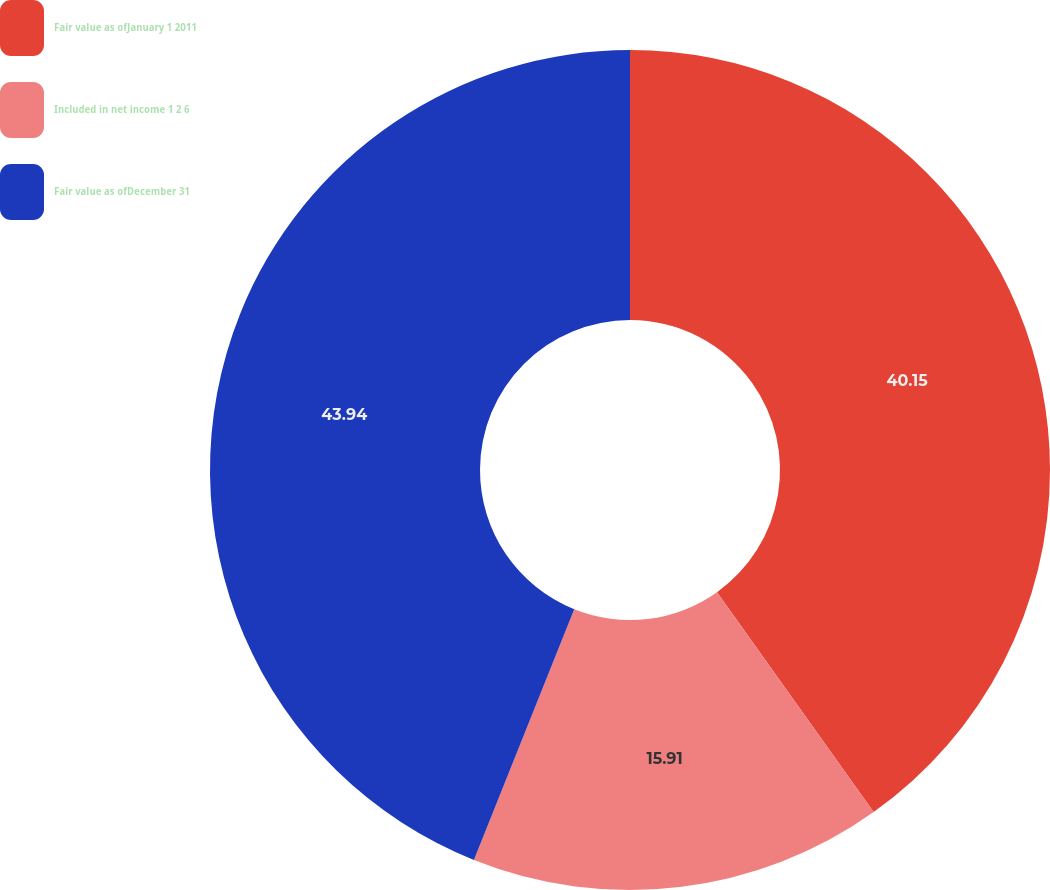Convert chart. <chart><loc_0><loc_0><loc_500><loc_500><pie_chart><fcel>Fair value as ofJanuary 1 2011<fcel>Included in net income 1 2 6<fcel>Fair value as ofDecember 31<nl><fcel>40.15%<fcel>15.91%<fcel>43.94%<nl></chart> 